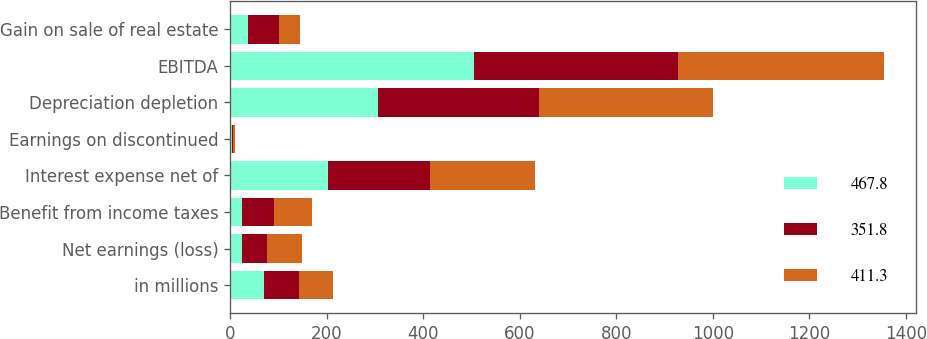Convert chart. <chart><loc_0><loc_0><loc_500><loc_500><stacked_bar_chart><ecel><fcel>in millions<fcel>Net earnings (loss)<fcel>Benefit from income taxes<fcel>Interest expense net of<fcel>Earnings on discontinued<fcel>Depreciation depletion<fcel>EBITDA<fcel>Gain on sale of real estate<nl><fcel>467.8<fcel>70.8<fcel>24.4<fcel>24.5<fcel>201.7<fcel>3.6<fcel>307.1<fcel>505.1<fcel>36.8<nl><fcel>351.8<fcel>70.8<fcel>52.6<fcel>66.5<fcel>211.9<fcel>1.3<fcel>332<fcel>423.5<fcel>65.1<nl><fcel>411.3<fcel>70.8<fcel>70.8<fcel>78.5<fcel>217.3<fcel>4.5<fcel>361.7<fcel>425.2<fcel>42.1<nl></chart> 